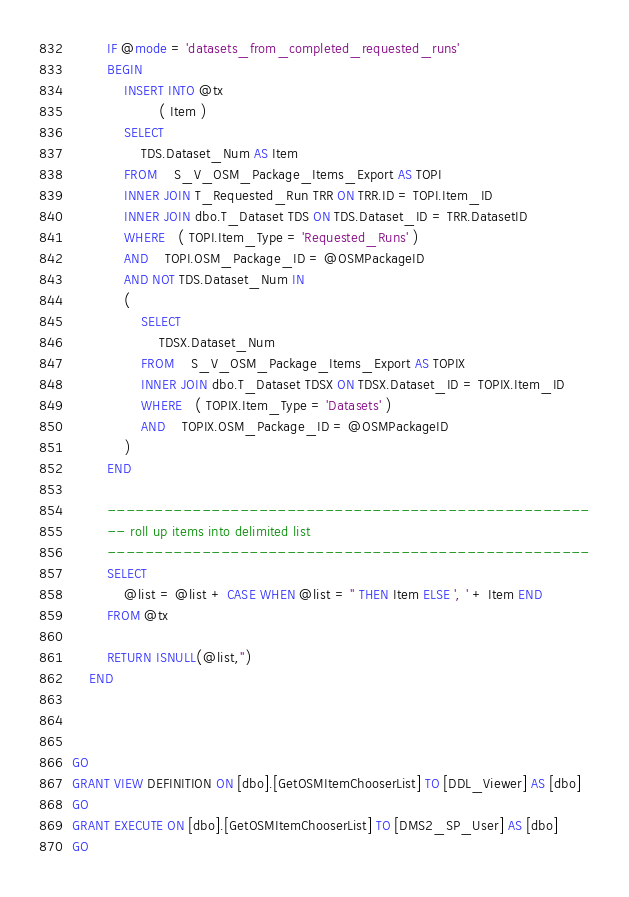Convert code to text. <code><loc_0><loc_0><loc_500><loc_500><_SQL_>  		IF @mode = 'datasets_from_completed_requested_runs'
 		BEGIN 
 			INSERT INTO @tx
 			        ( Item )	
 			SELECT 
				TDS.Dataset_Num AS Item
			FROM    S_V_OSM_Package_Items_Export AS TOPI
			INNER JOIN T_Requested_Run TRR ON TRR.ID = TOPI.Item_ID
			INNER JOIN dbo.T_Dataset TDS ON TDS.Dataset_ID = TRR.DatasetID
			WHERE   ( TOPI.Item_Type = 'Requested_Runs' )
 			AND 	TOPI.OSM_Package_ID = @OSMPackageID
			AND NOT TDS.Dataset_Num IN 
 			(
  				SELECT 
					TDSX.Dataset_Num
				FROM    S_V_OSM_Package_Items_Export AS TOPIX
				INNER JOIN dbo.T_Dataset TDSX ON TDSX.Dataset_ID = TOPIX.Item_ID
				WHERE   ( TOPIX.Item_Type = 'Datasets' )
 				AND 	TOPIX.OSM_Package_ID = @OSMPackageID
			)
 		END 			        						

  		---------------------------------------------------
 		-- roll up items into delimited list
		---------------------------------------------------
		SELECT 
 			@list = @list + CASE WHEN @list = '' THEN Item ELSE ', ' + Item END
 		FROM @tx

 		RETURN ISNULL(@list,'')
 	END



GO
GRANT VIEW DEFINITION ON [dbo].[GetOSMItemChooserList] TO [DDL_Viewer] AS [dbo]
GO
GRANT EXECUTE ON [dbo].[GetOSMItemChooserList] TO [DMS2_SP_User] AS [dbo]
GO
</code> 